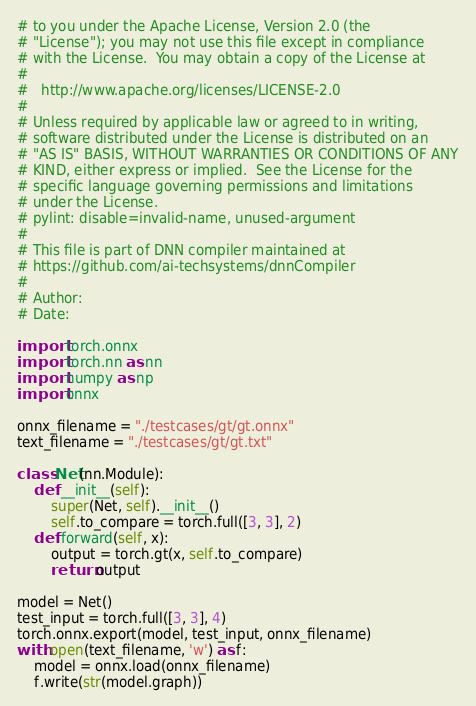Convert code to text. <code><loc_0><loc_0><loc_500><loc_500><_Python_># to you under the Apache License, Version 2.0 (the
# "License"); you may not use this file except in compliance
# with the License.  You may obtain a copy of the License at
#
#   http://www.apache.org/licenses/LICENSE-2.0
#
# Unless required by applicable law or agreed to in writing,
# software distributed under the License is distributed on an
# "AS IS" BASIS, WITHOUT WARRANTIES OR CONDITIONS OF ANY
# KIND, either express or implied.  See the License for the
# specific language governing permissions and limitations
# under the License.
# pylint: disable=invalid-name, unused-argument
#
# This file is part of DNN compiler maintained at 
# https://github.com/ai-techsystems/dnnCompiler
#
# Author:
# Date:

import torch.onnx
import torch.nn as nn
import numpy as np
import onnx

onnx_filename = "./testcases/gt/gt.onnx"
text_filename = "./testcases/gt/gt.txt"

class Net(nn.Module):
	def __init__(self):
		super(Net, self).__init__()
		self.to_compare = torch.full([3, 3], 2)
	def forward(self, x):
		output = torch.gt(x, self.to_compare)
		return output

model = Net()
test_input = torch.full([3, 3], 4)
torch.onnx.export(model, test_input, onnx_filename)
with open(text_filename, 'w') as f:
	model = onnx.load(onnx_filename)
	f.write(str(model.graph))</code> 